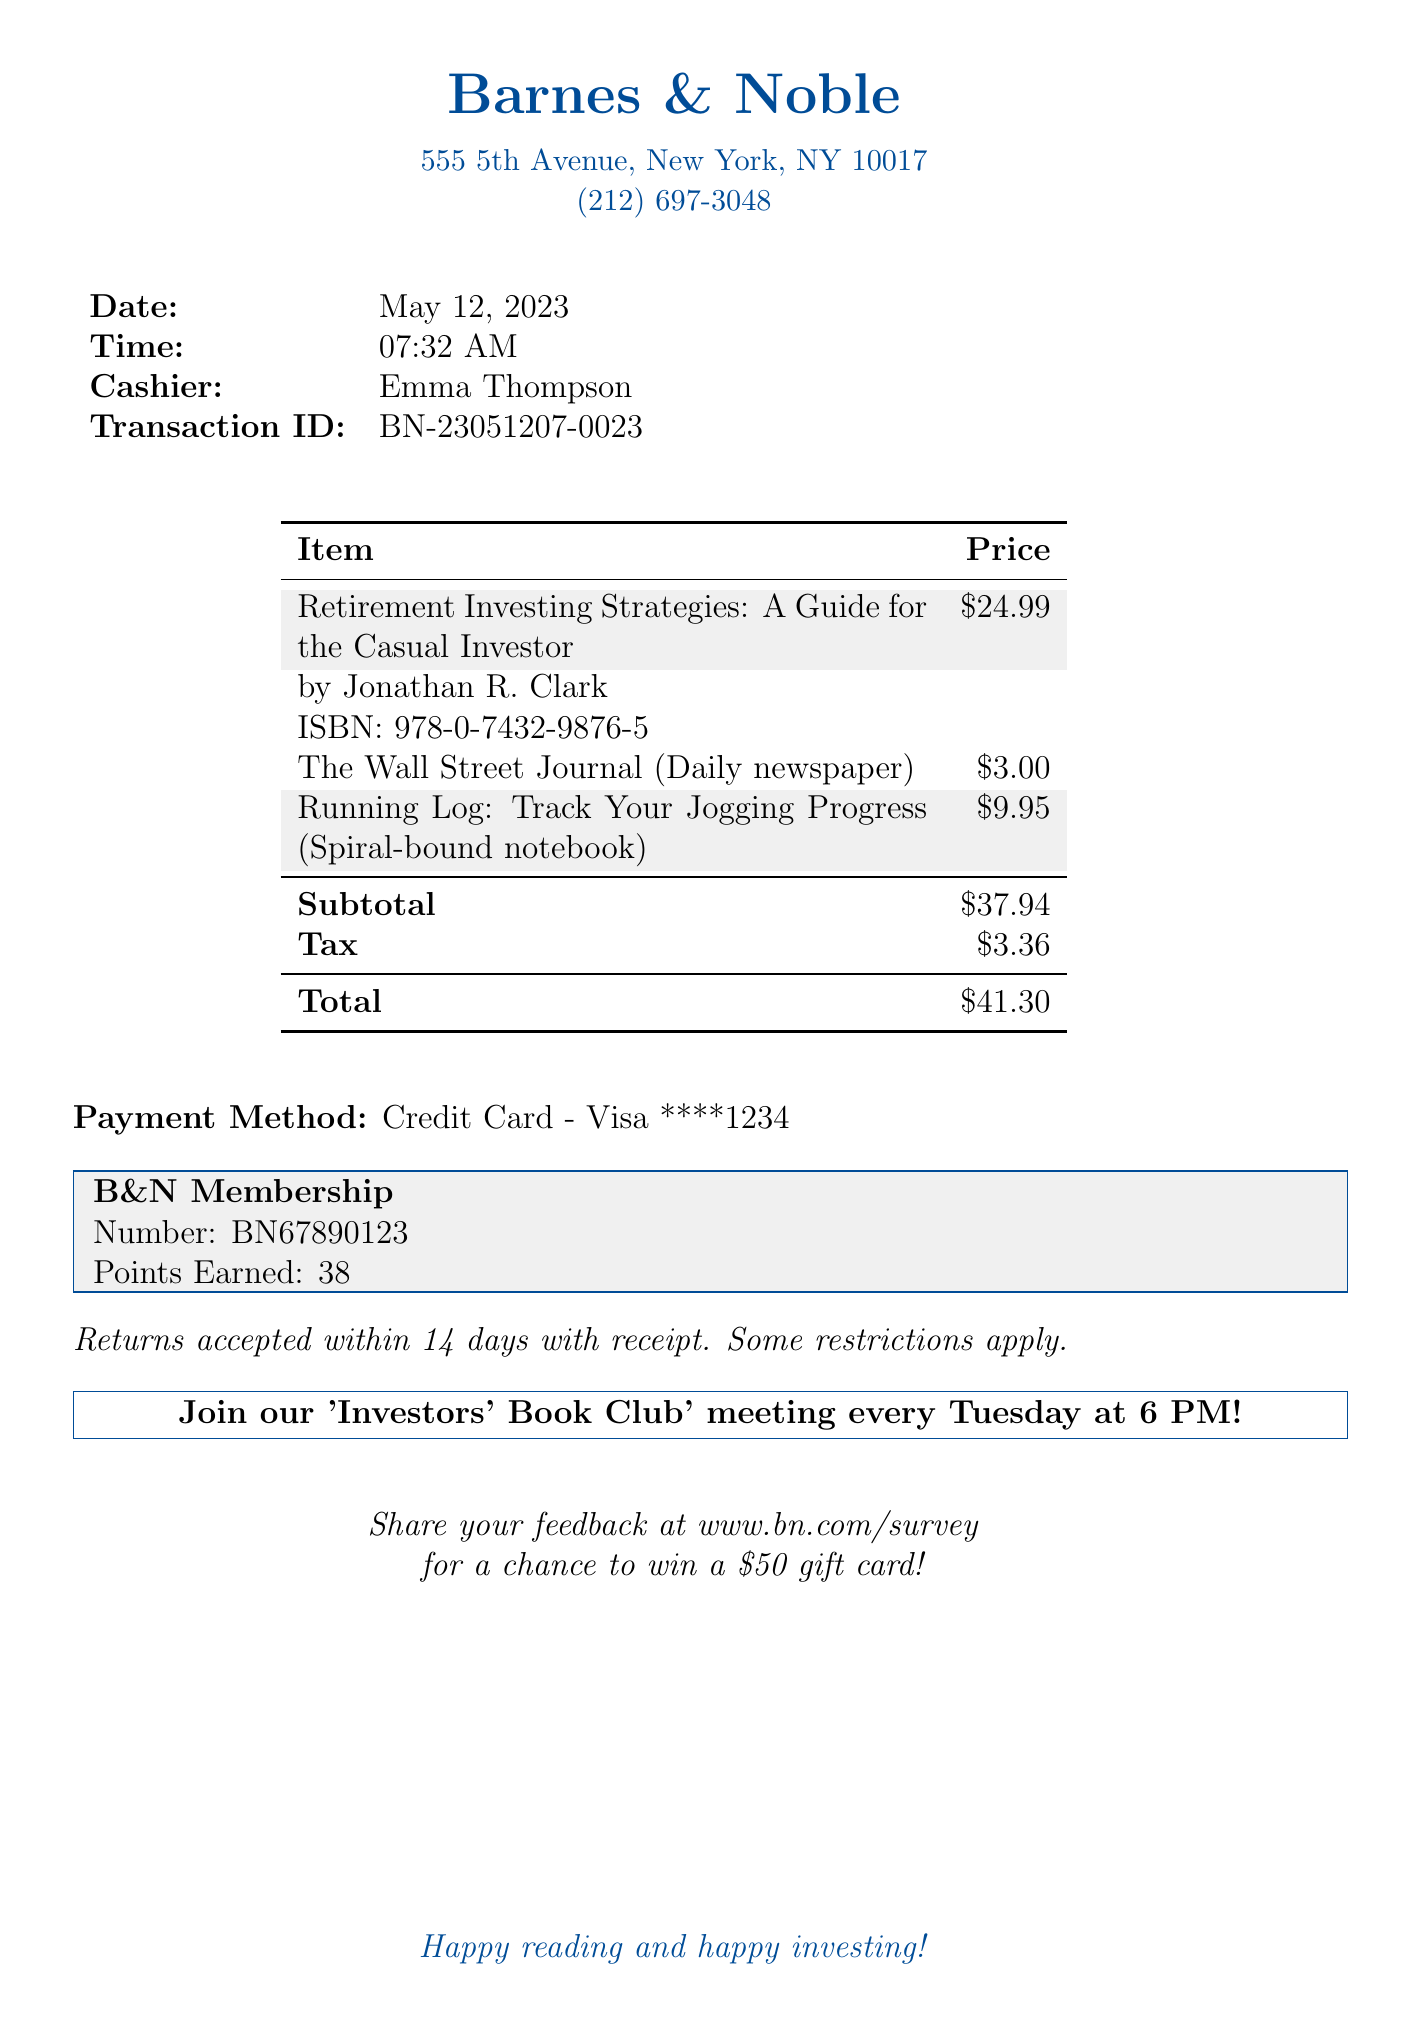What is the name of the store? The name of the store is stated at the top of the receipt.
Answer: Barnes & Noble What is the ISBN of the purchased book? The ISBN is provided in the item details for the book.
Answer: 978-0-7432-9876-5 Who was the cashier during the transaction? The cashier's name is listed in the transaction details.
Answer: Emma Thompson What is the total amount spent? The total amount is calculated and displayed at the bottom of the receipt.
Answer: $41.30 How many points were earned in the loyalty program? The points earned in the loyalty program are specified in the membership details.
Answer: 38 What is the purchase date? The date of the transaction is prominently displayed in the document.
Answer: May 12, 2023 What is the return policy described? The return policy outlines the conditions for returning items, which is found at the bottom of the document.
Answer: Returns accepted within 14 days with receipt How much tax was charged on the purchase? The tax amount is shown alongside the subtotal in the receipt.
Answer: $3.36 What promotional activity is mentioned in the receipt? The promotional activity details the weekly meeting mentioned towards the end of the document.
Answer: Investors' Book Club meeting every Tuesday at 6 PM! 